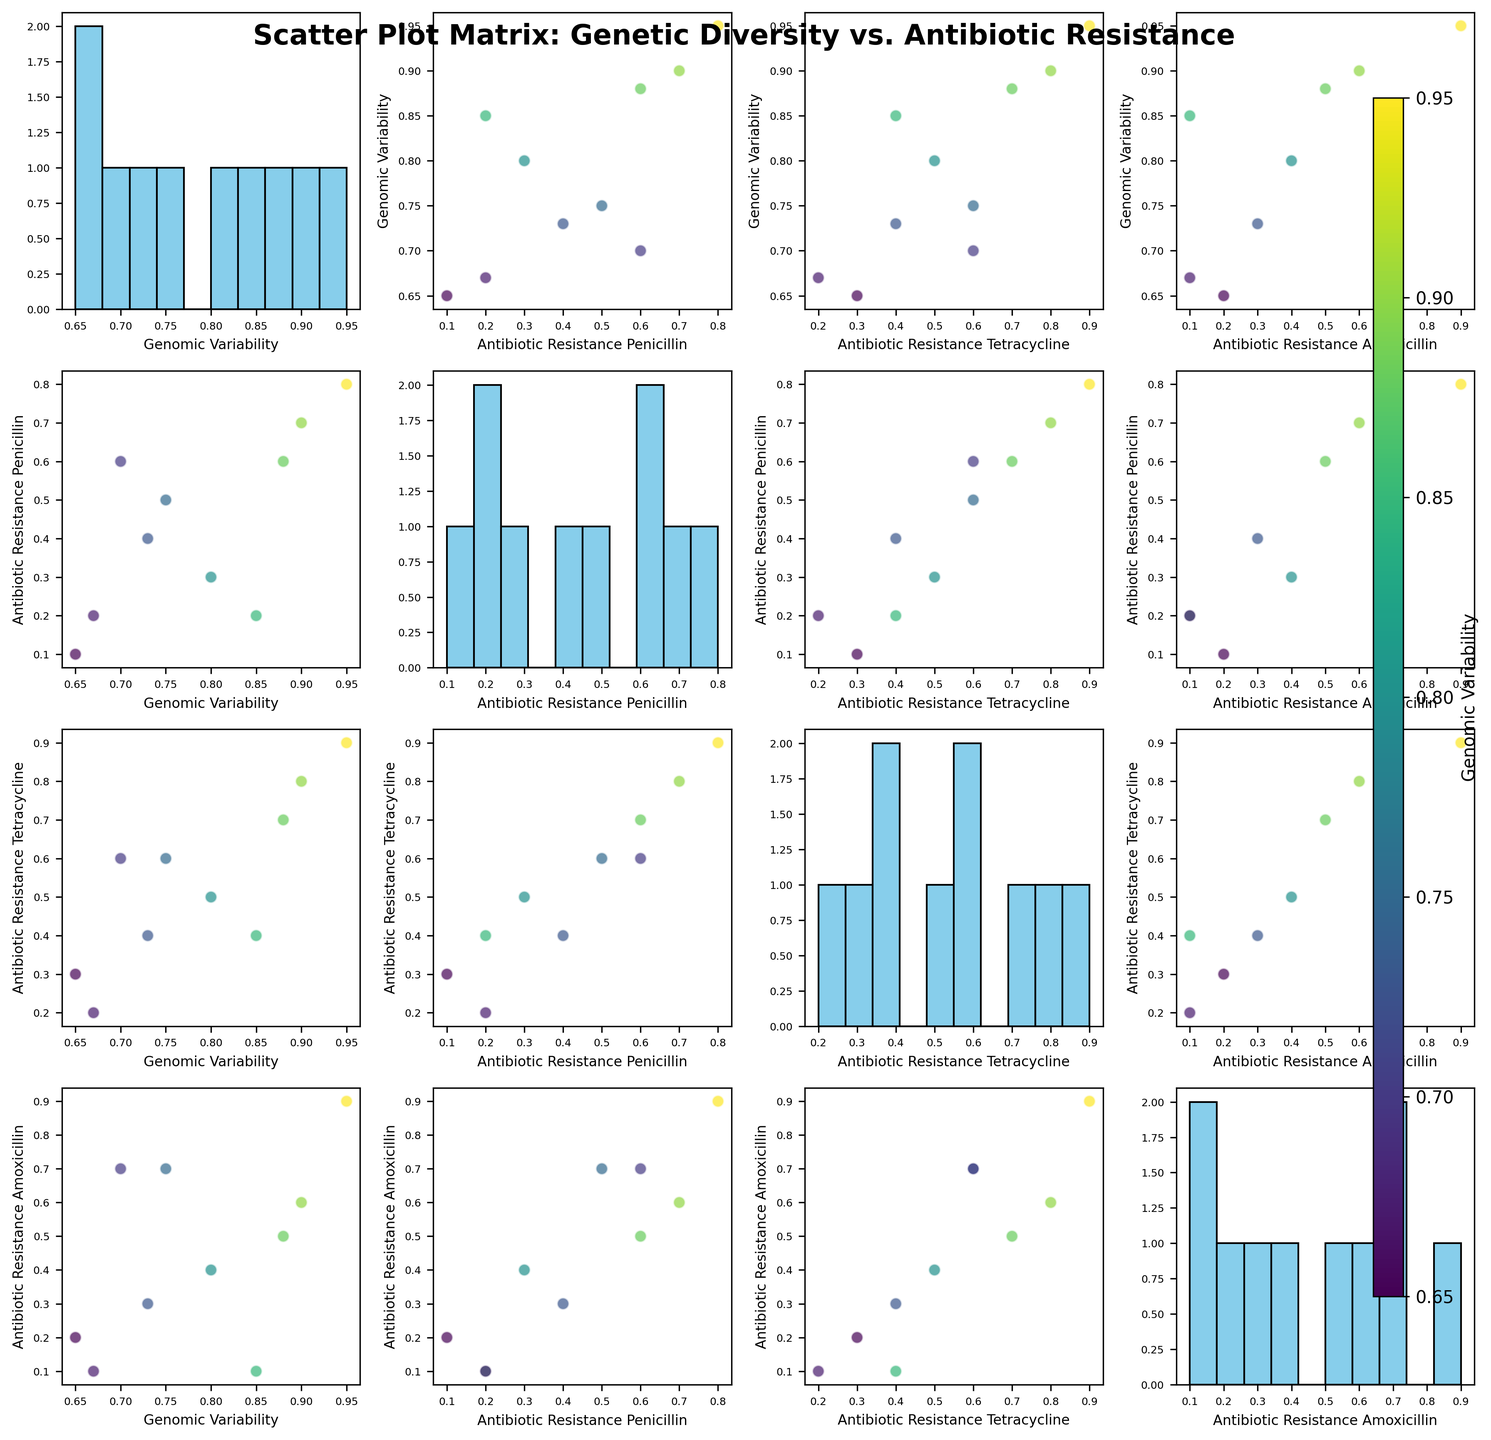How many subplots are in the Scatter Plot Matrix figure? The scatter plot matrix for this dataset plots 4 features against each other (Genomic Variability and 3 antibiotic resistance profiles). The matrix has a 4x4 grid, so there are 16 subplots in total.
Answer: 16 What is the title of the Scatter Plot Matrix figure? The title of the figure is positioned at the top center. From the figure, the title is "Scatter Plot Matrix: Genetic Diversity vs. Antibiotic Resistance".
Answer: Scatter Plot Matrix: Genetic Diversity vs. Antibiotic Resistance What does the color in the scatter plots represent? The color in the scatter plots represents the Genomic Variability of the bacterial strains. This can be inferred from the colorbar on the right side of the figure, which is labeled "Genomic Variability".
Answer: Genomic Variability Which bacterial strain exhibits the highest genomic variability? By looking at the color scale and the scatter plots where the color is the darkest (indicating highest values), Mycobacterium tuberculosis has the highest genomic variability at 0.95.
Answer: Mycobacterium tuberculosis Is there a positive correlation between genomic variability and antibiotic resistance to tetracycline? By observing the scatter plot of Genomic Variability against Antibiotic Resistance to Tetracycline, there seems to be a general trend where higher genomic variability corresponds to higher resistance, indicating a positive correlation.
Answer: Yes Among all bacterial strains, which one shows the highest resistance to all three antibiotics? By looking at the scatter plots for all three antibiotics, the strain with the highest resistance values (0.8 for Penicillin, 0.9 for Tetracycline, and 0.9 for Amoxicillin) is Mycobacterium tuberculosis.
Answer: Mycobacterium tuberculosis Which pair of antibiotic resistances shows the strongest correlation? By comparing the scatter plots between the pairs of antibiotic resistance profiles, the scatter plot of Penicillin and Tetracycline shows a strong positive correlation, meaning the resistance values tend to rise together.
Answer: Penicillin and Tetracycline Do the strains with lower genomic variability tend to have lower antibiotic resistance? By observing various scatter plots involving genomic variability and antibiotic resistances, strains with lower genomic variability (e.g., Bacillus subtilis, Haemophilus influenzae) generally show lower values of antibiotic resistance.
Answer: Yes Is there any bacterium that has low resistance (<0.2) to both Penicillin and Amoxicillin? By observing the individual scatter plots of Penicillin and Amoxicillin resistance against other features, Haemophilus influenzae shows resistance values of 0.2 and 0.1 for Penicillin and Amoxicillin, respectively.
Answer: Haemophilus influenzae 